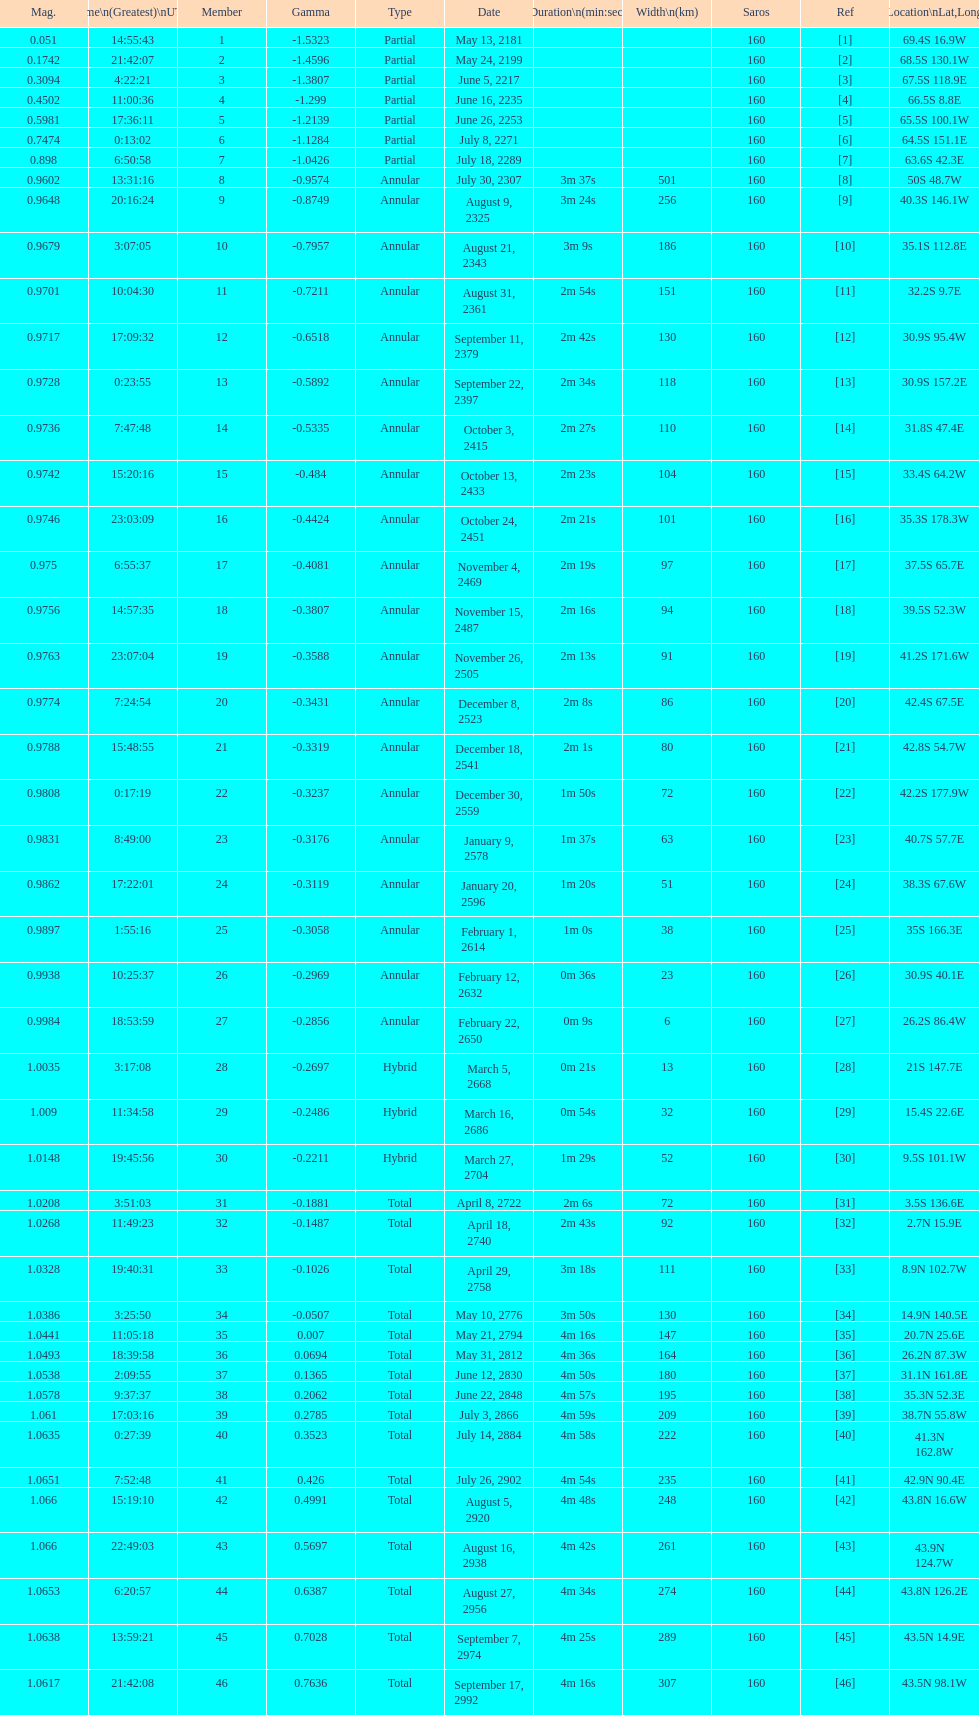When will the next solar saros be after the may 24, 2199 solar saros occurs? June 5, 2217. 